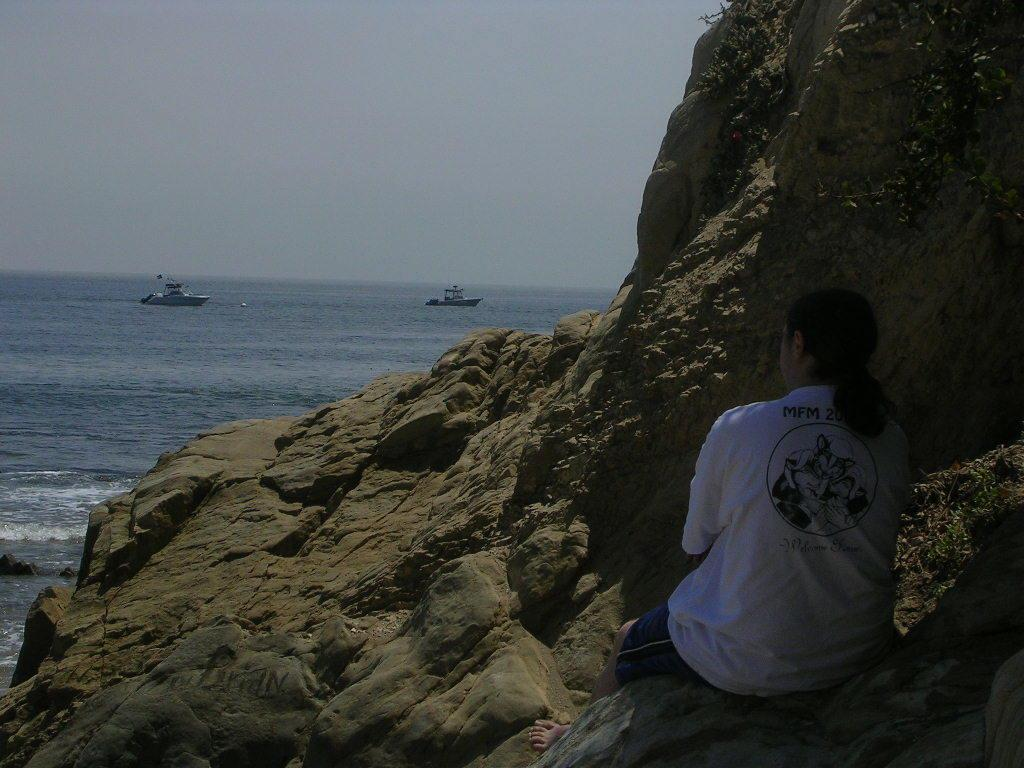What is the person in the image doing? There is a person sitting on a mountain in the image. What can be seen in the distance behind the person? There is a sea visible in the background of the image. Are there any other objects or structures visible in the image? Yes, there are two ships on the sea in the image. Can you see an ant kicking a finger in the image? No, there is no ant or finger present in the image. 